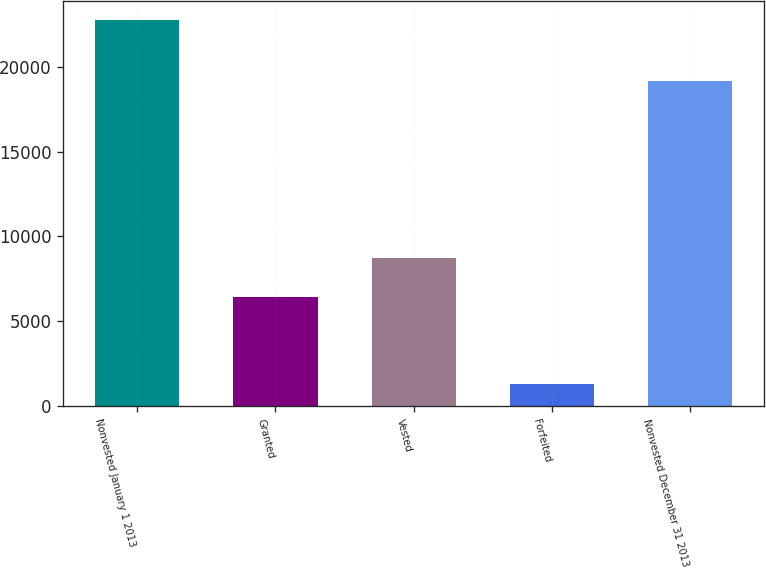<chart> <loc_0><loc_0><loc_500><loc_500><bar_chart><fcel>Nonvested January 1 2013<fcel>Granted<fcel>Vested<fcel>Forfeited<fcel>Nonvested December 31 2013<nl><fcel>22743<fcel>6394<fcel>8705<fcel>1298<fcel>19134<nl></chart> 